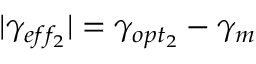<formula> <loc_0><loc_0><loc_500><loc_500>| \gamma _ { e f f _ { 2 } } | = \gamma _ { o p t _ { 2 } } - \gamma _ { m }</formula> 